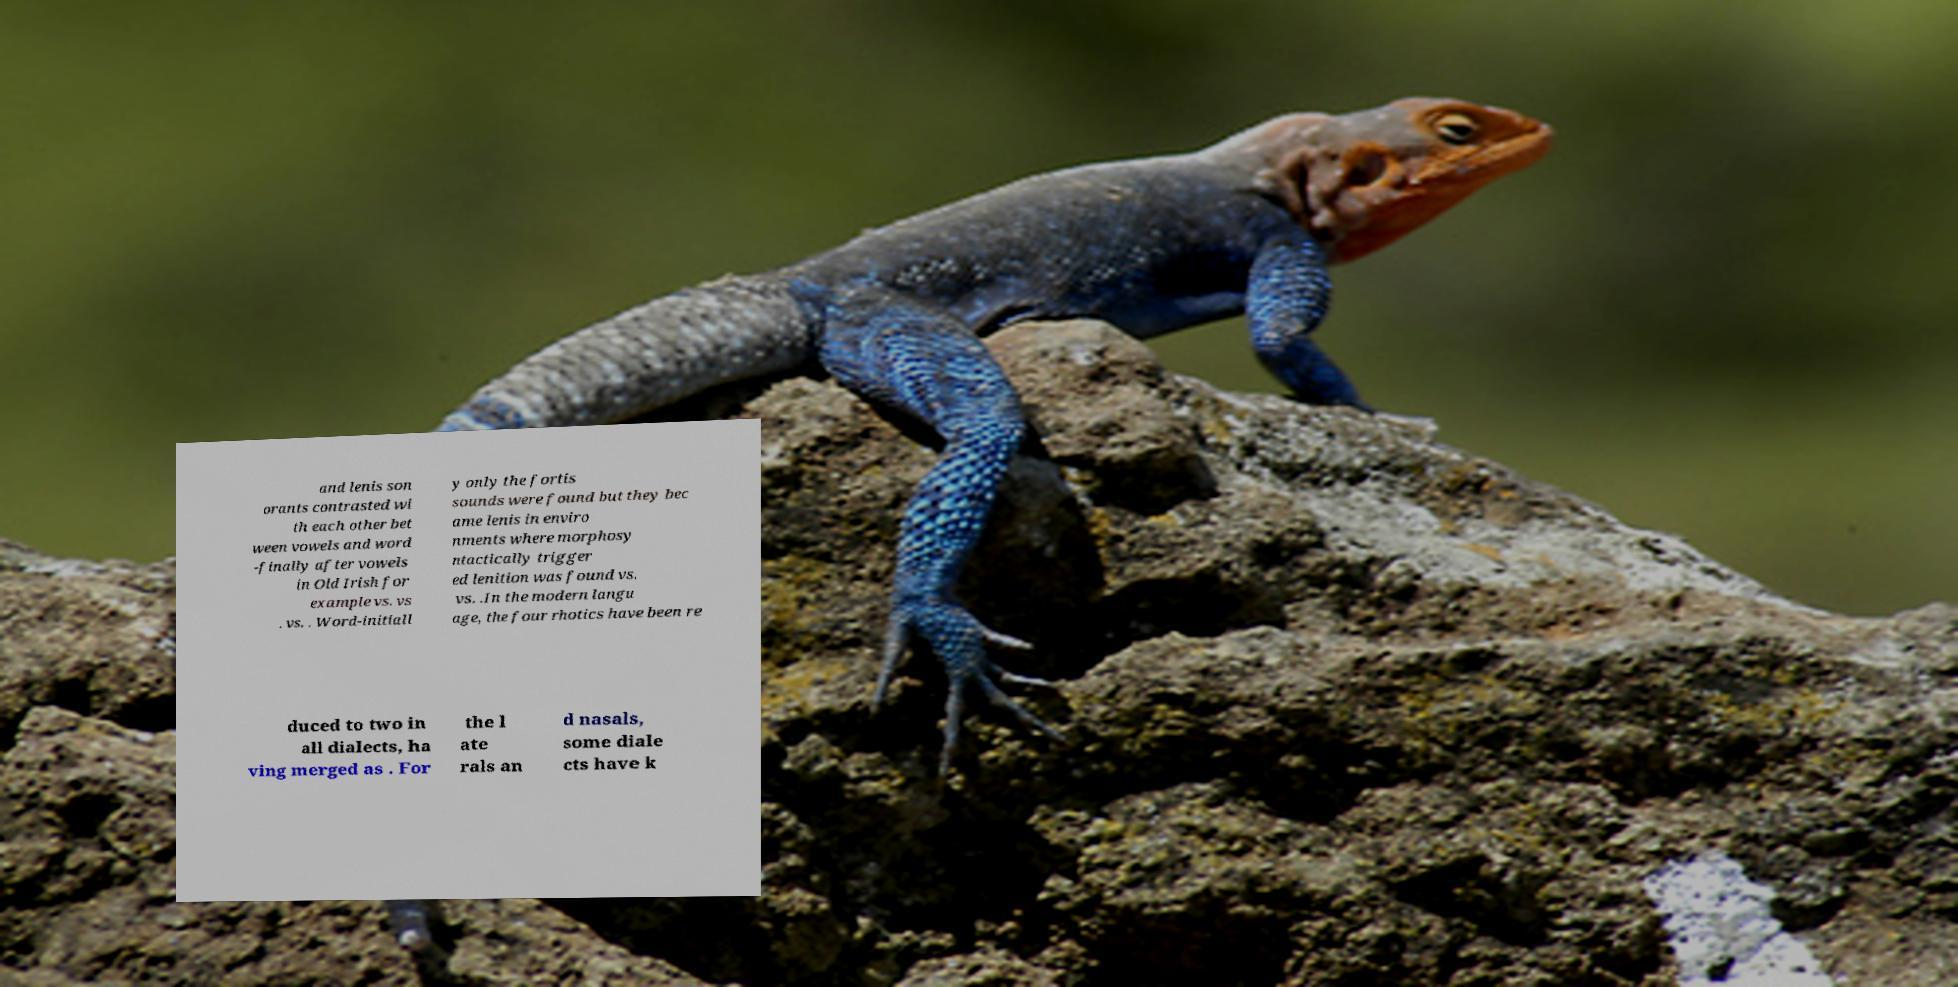I need the written content from this picture converted into text. Can you do that? and lenis son orants contrasted wi th each other bet ween vowels and word -finally after vowels in Old Irish for example vs. vs . vs. . Word-initiall y only the fortis sounds were found but they bec ame lenis in enviro nments where morphosy ntactically trigger ed lenition was found vs. vs. .In the modern langu age, the four rhotics have been re duced to two in all dialects, ha ving merged as . For the l ate rals an d nasals, some diale cts have k 